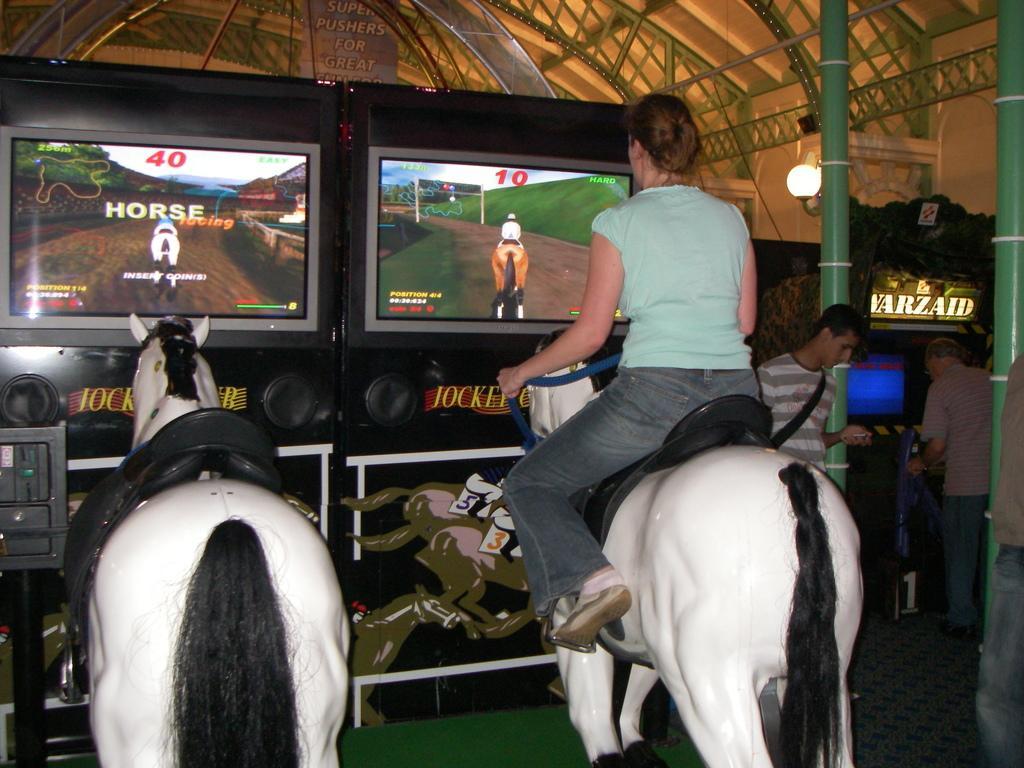In one or two sentences, can you explain what this image depicts? This image is taken indoors. At the bottom of the image there is a floor. In the middle of the image there are artificial horses and a woman is sitting on the horse and playing video games. On the right side of the image two men are standing on the floor and there is a board with a text on it. At the top of the image there is a roof with iron bars and grills. 